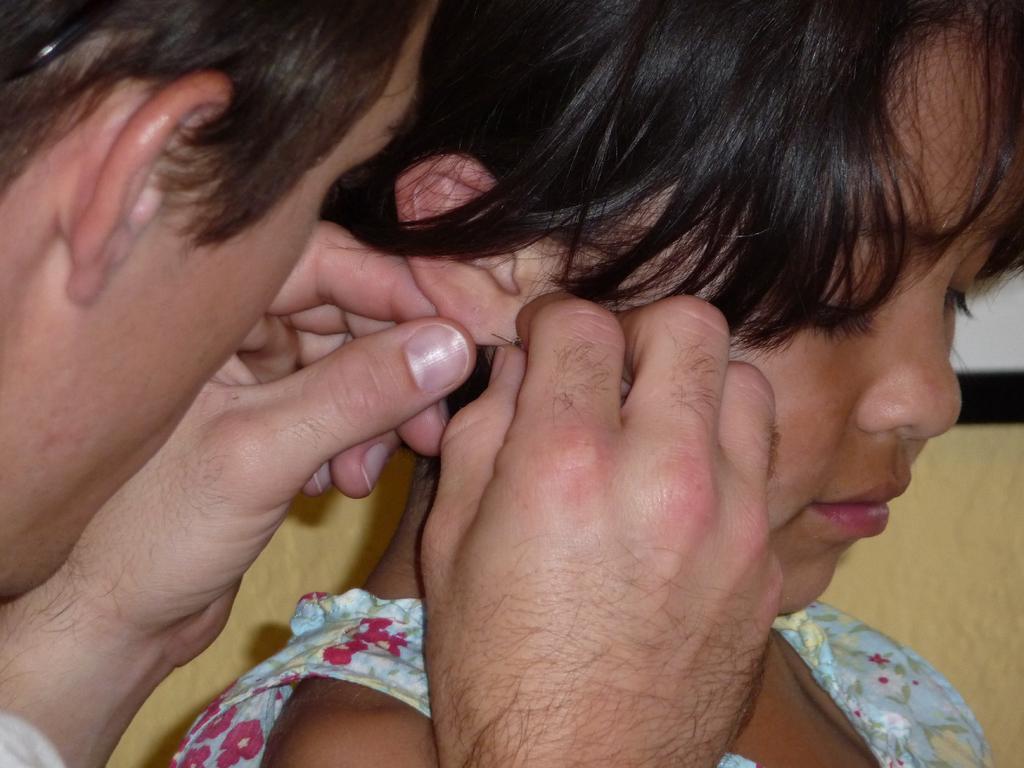Describe this image in one or two sentences. In this image I can see there are two persons visible and one person holding a needle. 